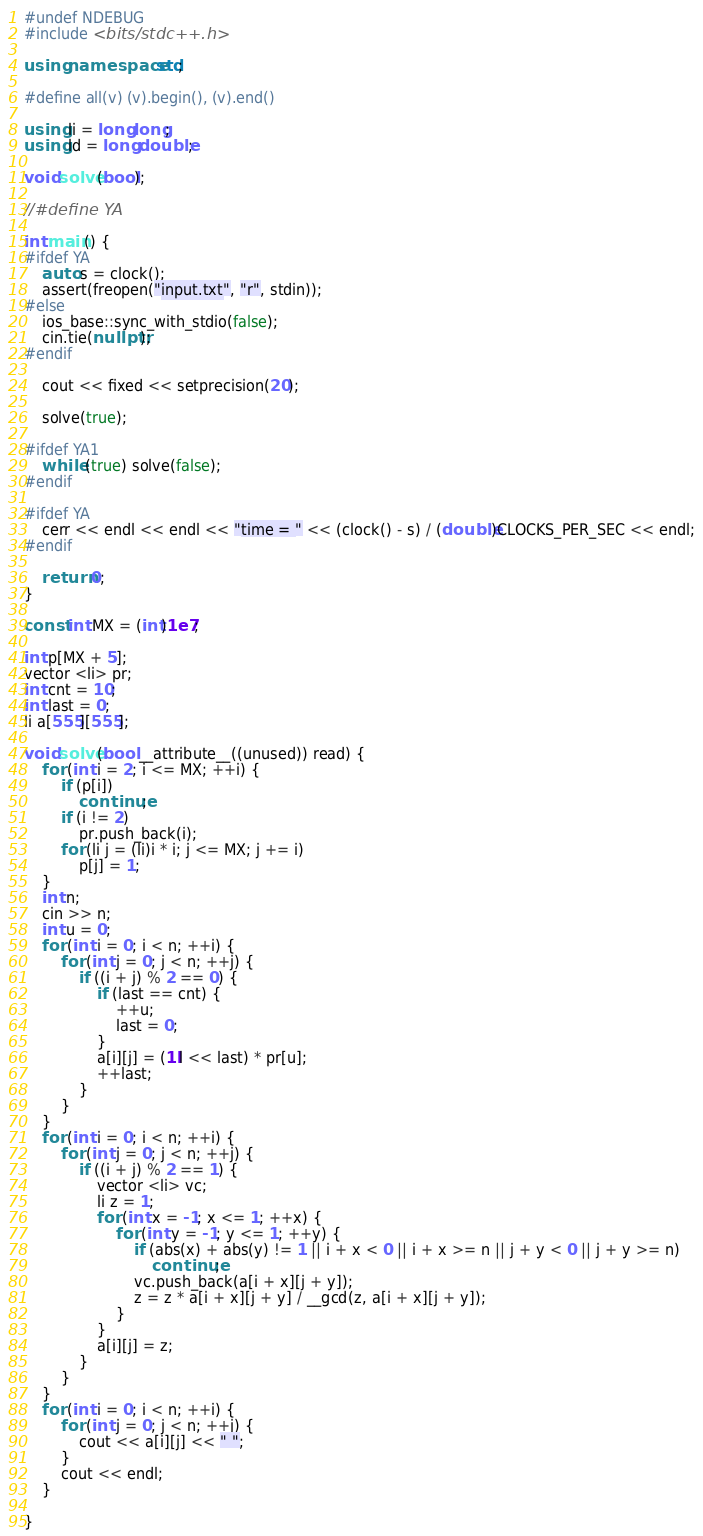Convert code to text. <code><loc_0><loc_0><loc_500><loc_500><_C++_>#undef NDEBUG
#include <bits/stdc++.h>

using namespace std;

#define all(v) (v).begin(), (v).end()

using li = long long;
using ld = long double;

void solve(bool);

//#define YA

int main() {
#ifdef YA
    auto s = clock();
    assert(freopen("input.txt", "r", stdin));
#else
    ios_base::sync_with_stdio(false);
    cin.tie(nullptr);
#endif

    cout << fixed << setprecision(20);

    solve(true);

#ifdef YA1
    while (true) solve(false);
#endif

#ifdef YA
    cerr << endl << endl << "time = " << (clock() - s) / (double)CLOCKS_PER_SEC << endl;
#endif

    return 0;
}

const int MX = (int)1e7;

int p[MX + 5];
vector <li> pr;
int cnt = 10;
int last = 0;
li a[555][555];

void solve(bool __attribute__((unused)) read) {
    for (int i = 2; i <= MX; ++i) {
        if (p[i])
            continue;
        if (i != 2)
            pr.push_back(i);
        for (li j = (li)i * i; j <= MX; j += i)
            p[j] = 1;
    }
    int n;
    cin >> n;
    int u = 0;
    for (int i = 0; i < n; ++i) {
        for (int j = 0; j < n; ++j) {
            if ((i + j) % 2 == 0) {
                if (last == cnt) {
                    ++u;
                    last = 0;
                }
                a[i][j] = (1ll << last) * pr[u];
                ++last;
            }
        }
    }
    for (int i = 0; i < n; ++i) {
        for (int j = 0; j < n; ++j) {
            if ((i + j) % 2 == 1) {
                vector <li> vc;
                li z = 1;
                for (int x = -1; x <= 1; ++x) {
                    for (int y = -1; y <= 1; ++y) {
                        if (abs(x) + abs(y) != 1 || i + x < 0 || i + x >= n || j + y < 0 || j + y >= n)
                            continue;
                        vc.push_back(a[i + x][j + y]);
                        z = z * a[i + x][j + y] / __gcd(z, a[i + x][j + y]);
                    }
                }
                a[i][j] = z;
            }
        }
    }
    for (int i = 0; i < n; ++i) {
        for (int j = 0; j < n; ++j) {
            cout << a[i][j] << " ";
        }
        cout << endl;
    }

}</code> 